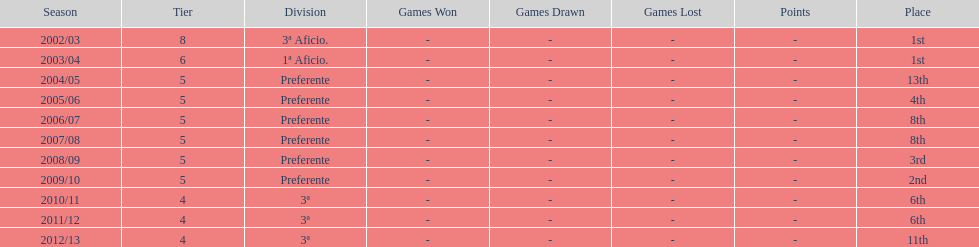How many seasons did internacional de madrid cf play in the preferente division? 6. 